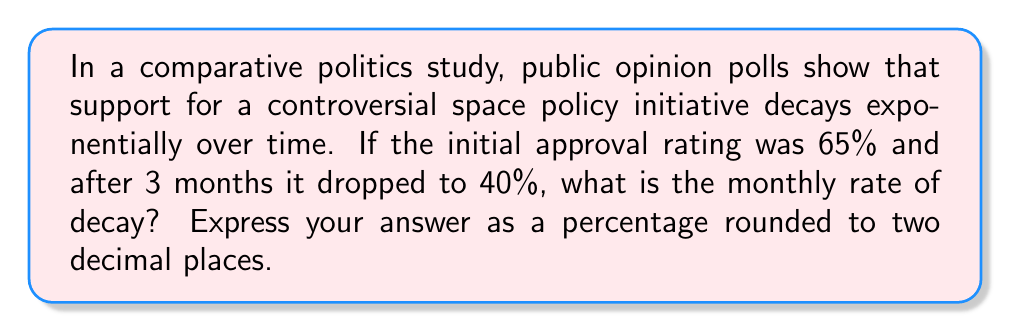Solve this math problem. Let's approach this step-by-step using an exponential decay function:

1) The general form of exponential decay is:
   $A(t) = A_0 \cdot (1-r)^t$

   Where:
   $A(t)$ is the amount at time $t$
   $A_0$ is the initial amount
   $r$ is the rate of decay (as a decimal)
   $t$ is the time

2) We know:
   $A_0 = 65\%$
   $A(3) = 40\%$
   $t = 3$ months

3) Let's plug these into our equation:
   $40 = 65 \cdot (1-r)^3$

4) Divide both sides by 65:
   $\frac{40}{65} = (1-r)^3$

5) Take the cube root of both sides:
   $\sqrt[3]{\frac{40}{65}} = 1-r$

6) Subtract both sides from 1:
   $1 - \sqrt[3]{\frac{40}{65}} = r$

7) Calculate:
   $r = 1 - \sqrt[3]{\frac{40}{65}} \approx 0.1484$

8) Convert to a percentage:
   $0.1484 \times 100\% = 14.84\%$

9) Round to two decimal places:
   $14.84\% \approx 14.84\%$
Answer: 14.84% 